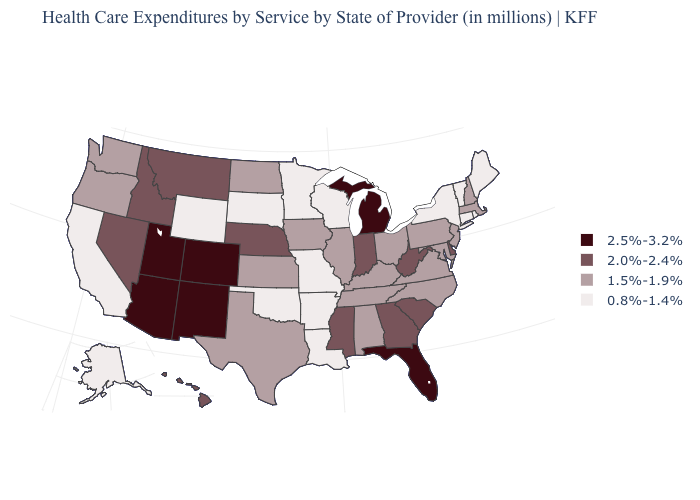Which states have the lowest value in the South?
Write a very short answer. Arkansas, Louisiana, Oklahoma. Is the legend a continuous bar?
Answer briefly. No. Name the states that have a value in the range 0.8%-1.4%?
Concise answer only. Alaska, Arkansas, California, Connecticut, Louisiana, Maine, Minnesota, Missouri, New York, Oklahoma, Rhode Island, South Dakota, Vermont, Wisconsin, Wyoming. Name the states that have a value in the range 0.8%-1.4%?
Quick response, please. Alaska, Arkansas, California, Connecticut, Louisiana, Maine, Minnesota, Missouri, New York, Oklahoma, Rhode Island, South Dakota, Vermont, Wisconsin, Wyoming. Which states hav the highest value in the West?
Keep it brief. Arizona, Colorado, New Mexico, Utah. What is the value of Missouri?
Concise answer only. 0.8%-1.4%. What is the highest value in the Northeast ?
Keep it brief. 1.5%-1.9%. What is the value of South Dakota?
Short answer required. 0.8%-1.4%. Does New Mexico have the lowest value in the USA?
Be succinct. No. What is the value of Delaware?
Write a very short answer. 2.0%-2.4%. Name the states that have a value in the range 2.0%-2.4%?
Short answer required. Delaware, Georgia, Hawaii, Idaho, Indiana, Mississippi, Montana, Nebraska, Nevada, South Carolina, West Virginia. Among the states that border Minnesota , does North Dakota have the highest value?
Quick response, please. Yes. Does the first symbol in the legend represent the smallest category?
Write a very short answer. No. What is the highest value in states that border Vermont?
Keep it brief. 1.5%-1.9%. Does the first symbol in the legend represent the smallest category?
Concise answer only. No. 